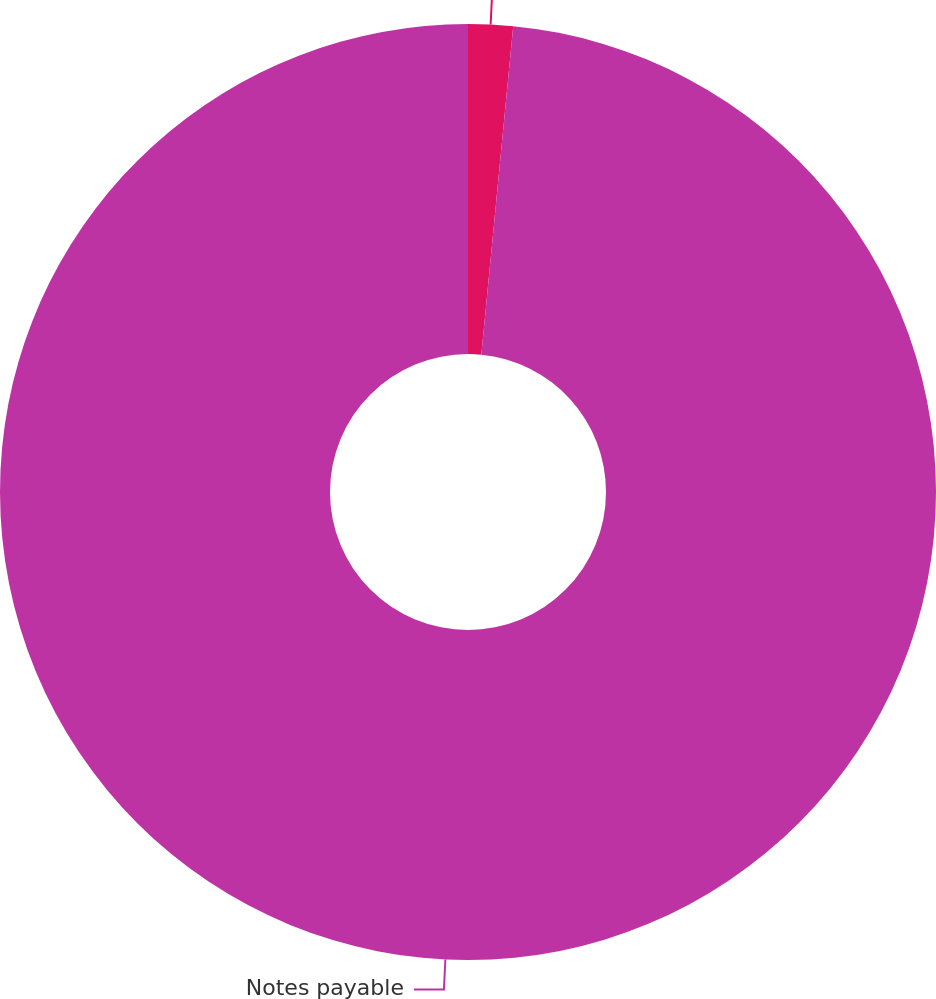<chart> <loc_0><loc_0><loc_500><loc_500><pie_chart><fcel>Notes receivable issued in<fcel>Notes payable<nl><fcel>1.54%<fcel>98.46%<nl></chart> 